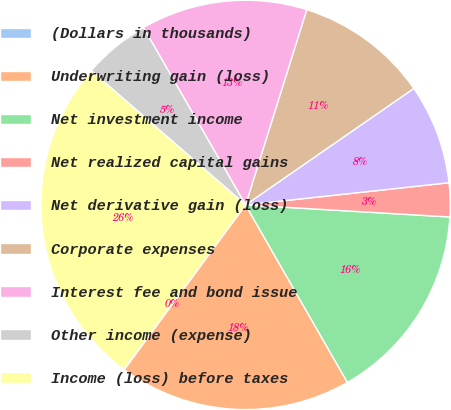Convert chart to OTSL. <chart><loc_0><loc_0><loc_500><loc_500><pie_chart><fcel>(Dollars in thousands)<fcel>Underwriting gain (loss)<fcel>Net investment income<fcel>Net realized capital gains<fcel>Net derivative gain (loss)<fcel>Corporate expenses<fcel>Interest fee and bond issue<fcel>Other income (expense)<fcel>Income (loss) before taxes<nl><fcel>0.05%<fcel>18.39%<fcel>15.77%<fcel>2.67%<fcel>7.91%<fcel>10.53%<fcel>13.15%<fcel>5.29%<fcel>26.25%<nl></chart> 